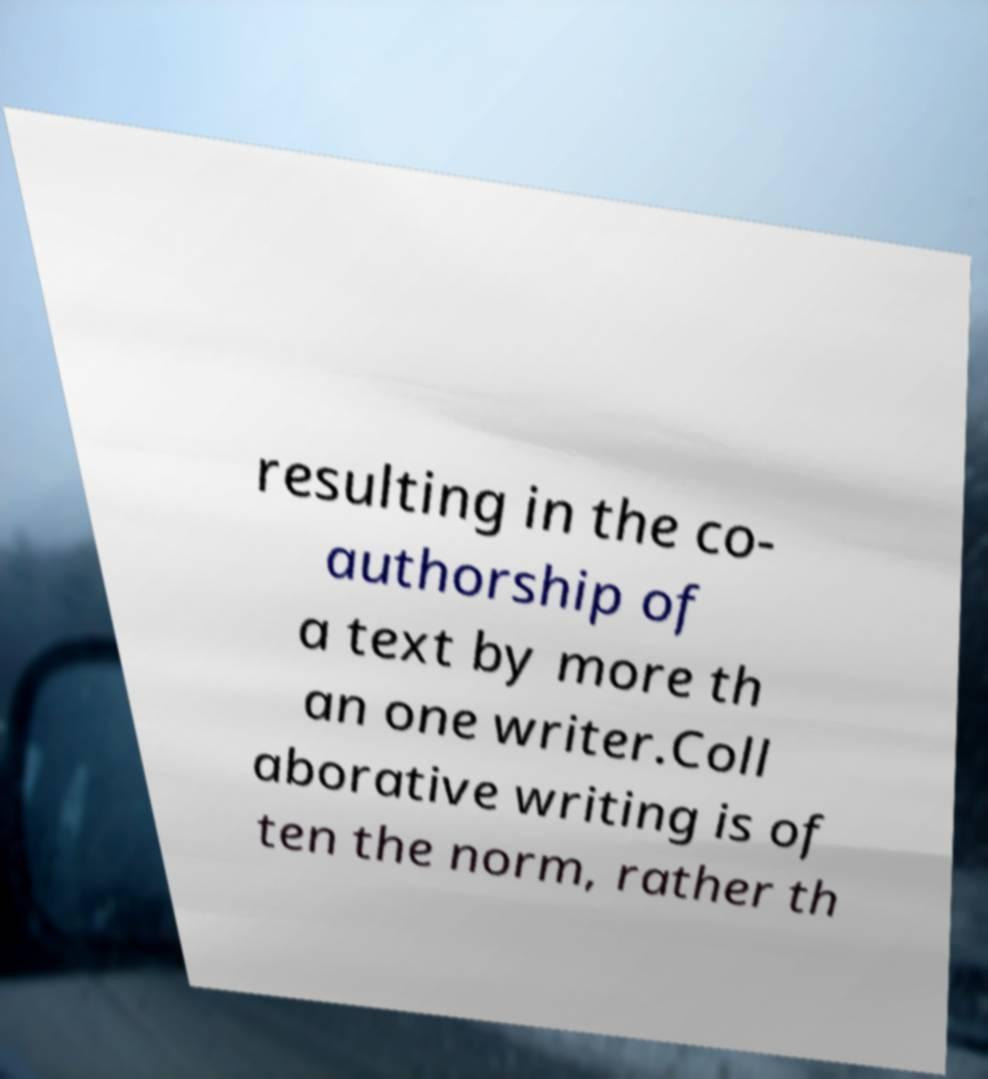For documentation purposes, I need the text within this image transcribed. Could you provide that? resulting in the co- authorship of a text by more th an one writer.Coll aborative writing is of ten the norm, rather th 